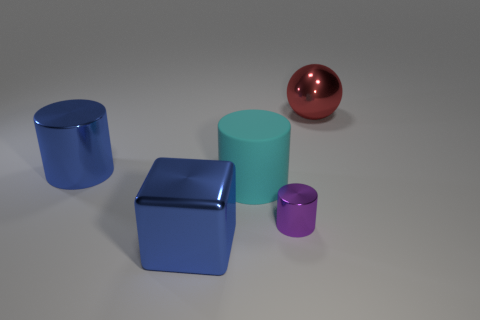Add 3 large cyan things. How many objects exist? 8 Subtract all cylinders. How many objects are left? 2 Add 2 large cubes. How many large cubes exist? 3 Subtract 0 gray blocks. How many objects are left? 5 Subtract all large shiny things. Subtract all tiny green shiny balls. How many objects are left? 2 Add 3 large cylinders. How many large cylinders are left? 5 